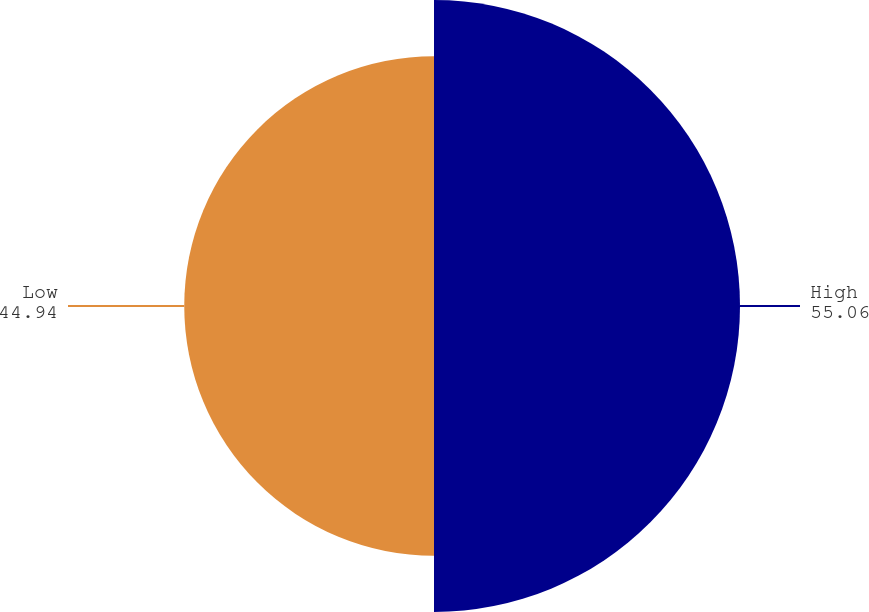Convert chart. <chart><loc_0><loc_0><loc_500><loc_500><pie_chart><fcel>High<fcel>Low<nl><fcel>55.06%<fcel>44.94%<nl></chart> 